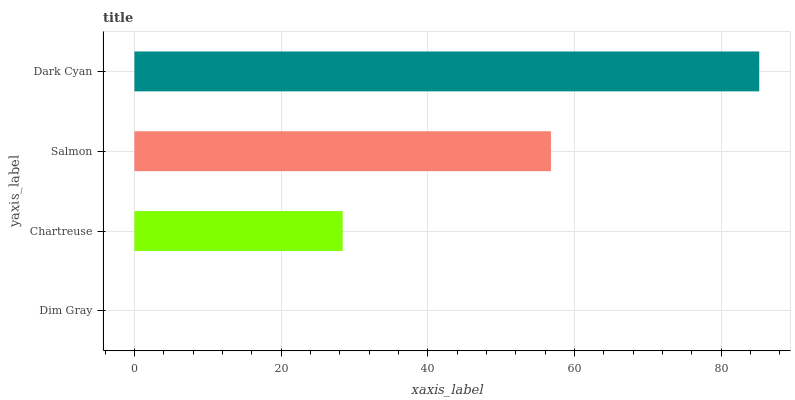Is Dim Gray the minimum?
Answer yes or no. Yes. Is Dark Cyan the maximum?
Answer yes or no. Yes. Is Chartreuse the minimum?
Answer yes or no. No. Is Chartreuse the maximum?
Answer yes or no. No. Is Chartreuse greater than Dim Gray?
Answer yes or no. Yes. Is Dim Gray less than Chartreuse?
Answer yes or no. Yes. Is Dim Gray greater than Chartreuse?
Answer yes or no. No. Is Chartreuse less than Dim Gray?
Answer yes or no. No. Is Salmon the high median?
Answer yes or no. Yes. Is Chartreuse the low median?
Answer yes or no. Yes. Is Dim Gray the high median?
Answer yes or no. No. Is Dark Cyan the low median?
Answer yes or no. No. 